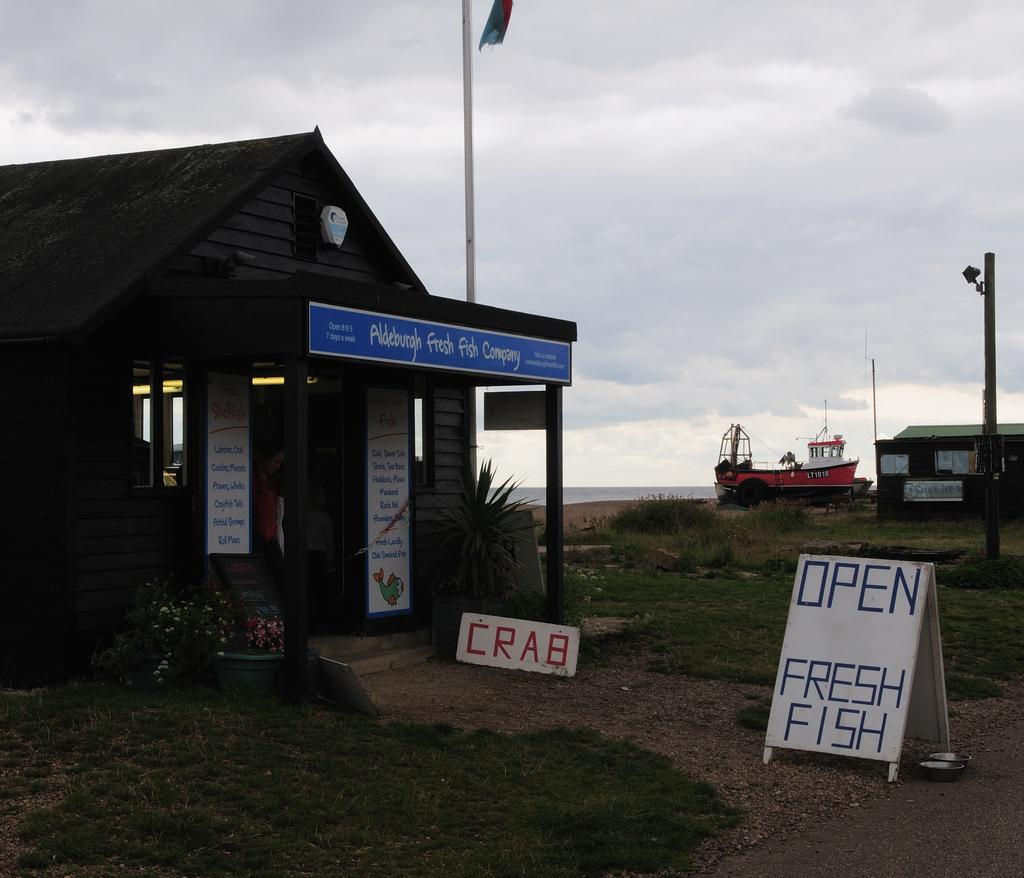What is the main object in the image? There is a board in the image. What type of natural environment is visible in the image? There is grass in the image. What type of plants can be seen in the image? There are houseplants in the image. What type of structures are present in the image? There are houses in the image. What is the tall, vertical object in the image? There is a flagpole in the image. What can be seen in the background of the image? There is a boat visible in the background. What part of the natural environment is visible in the image? The sky is visible in the image. When was the image taken? The image was taken during the day. What type of mint can be seen growing near the houseplants in the image? There is no mint visible in the image; only houseplants are present. How many beans are visible on the board in the image? There are no beans visible on the board in the image. 